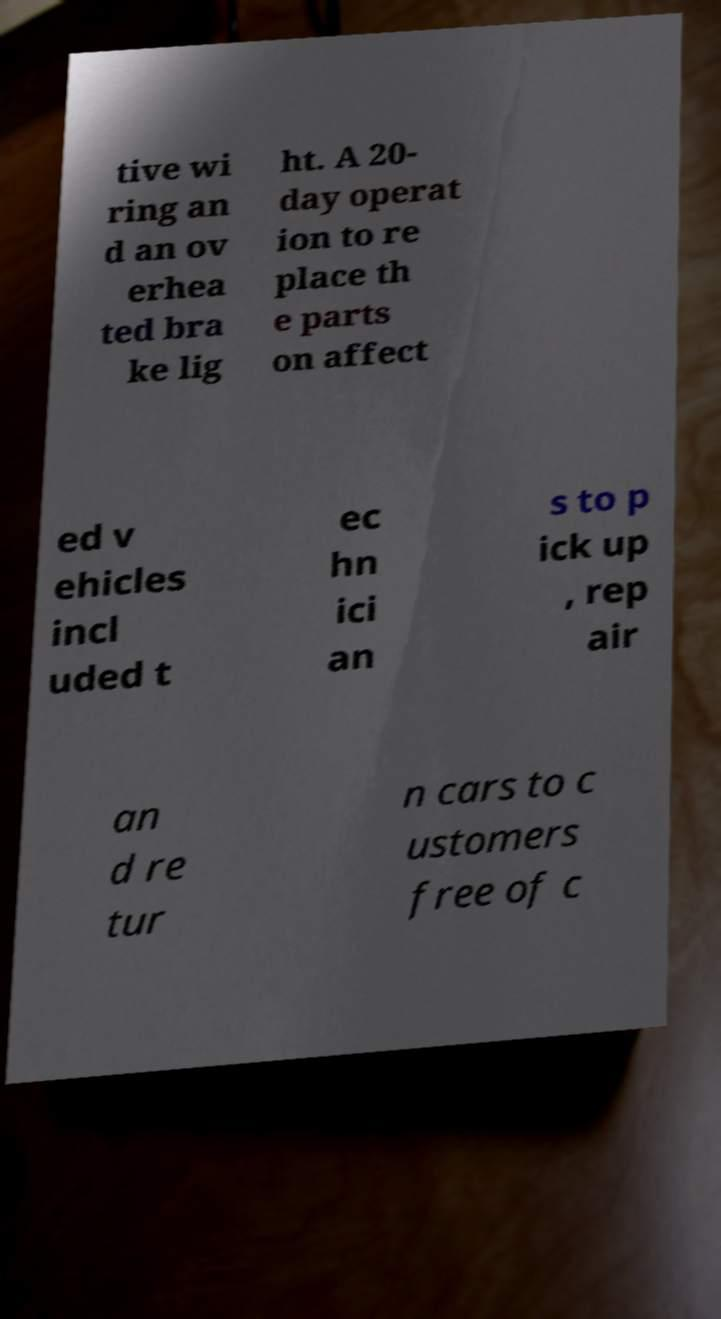What messages or text are displayed in this image? I need them in a readable, typed format. tive wi ring an d an ov erhea ted bra ke lig ht. A 20- day operat ion to re place th e parts on affect ed v ehicles incl uded t ec hn ici an s to p ick up , rep air an d re tur n cars to c ustomers free of c 